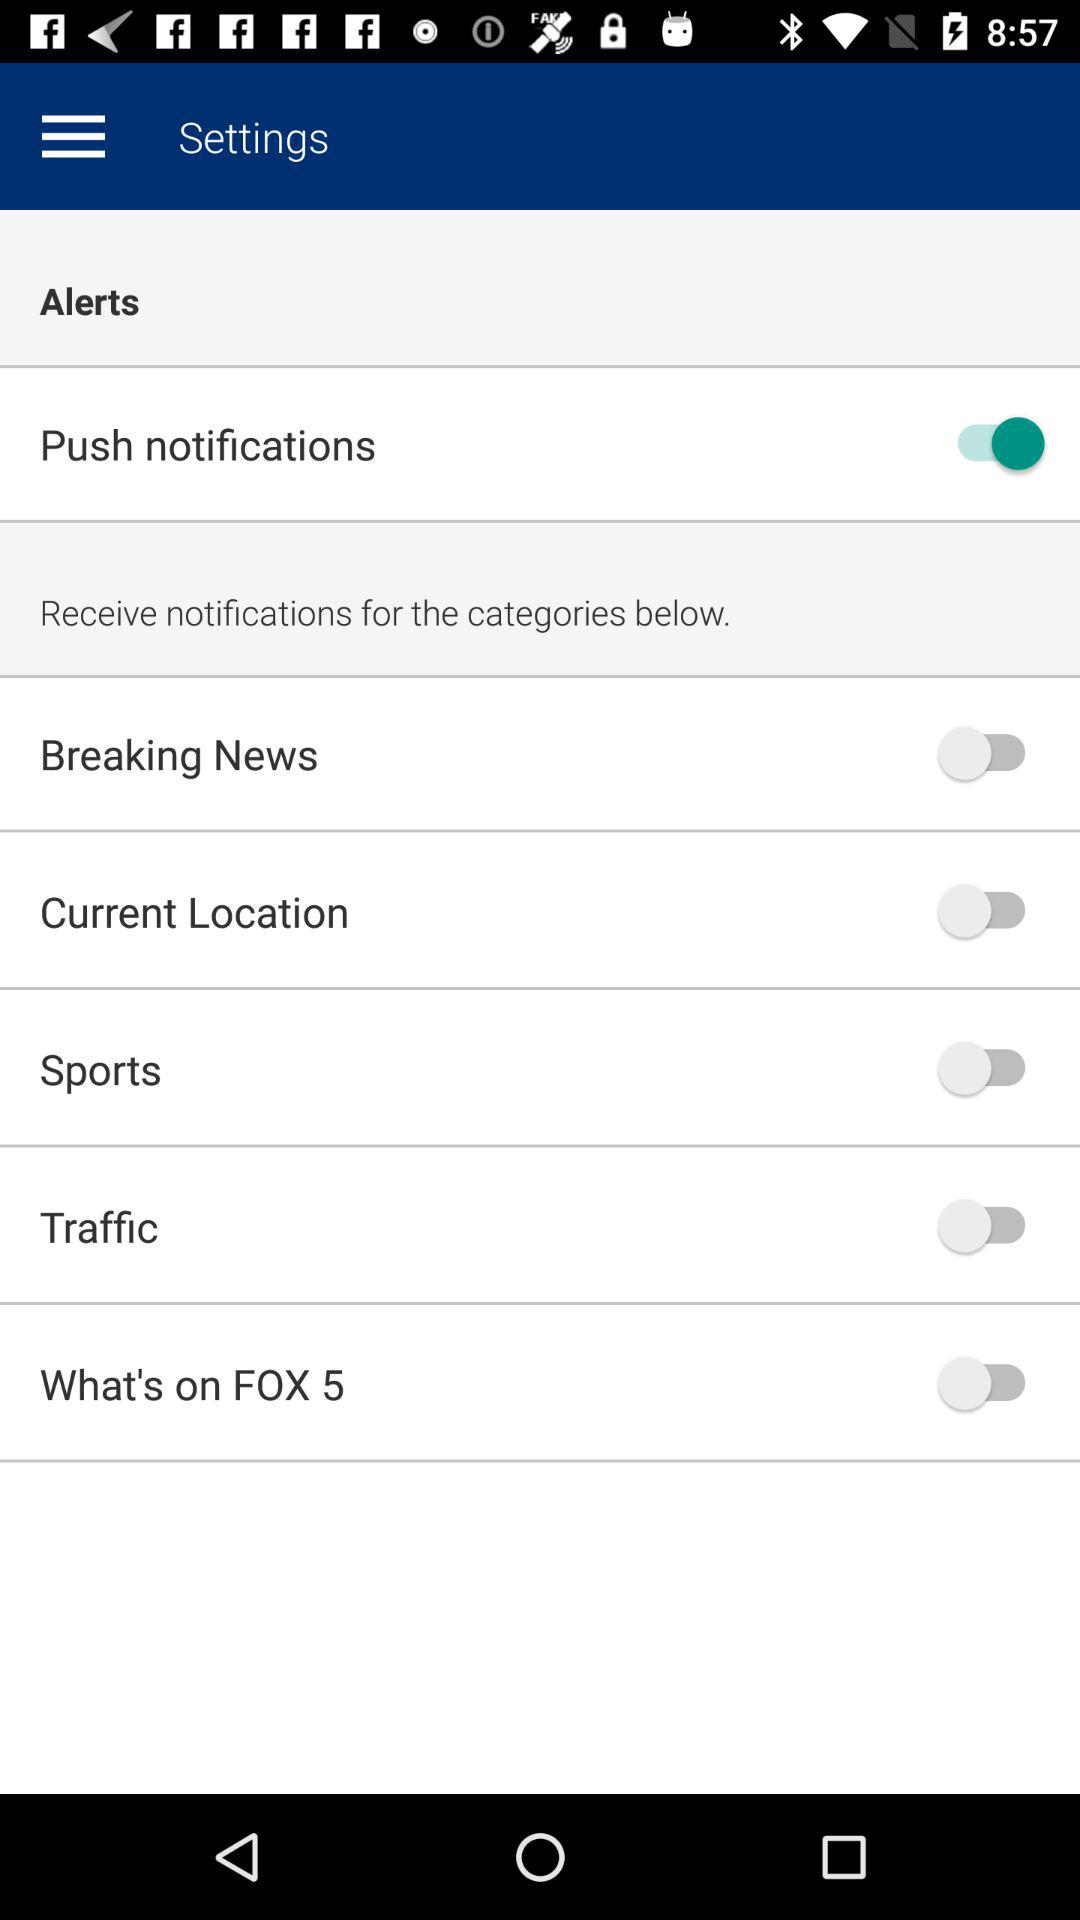What is the current status of "Breaking News"? The current status of "Breaking News" is "off". 